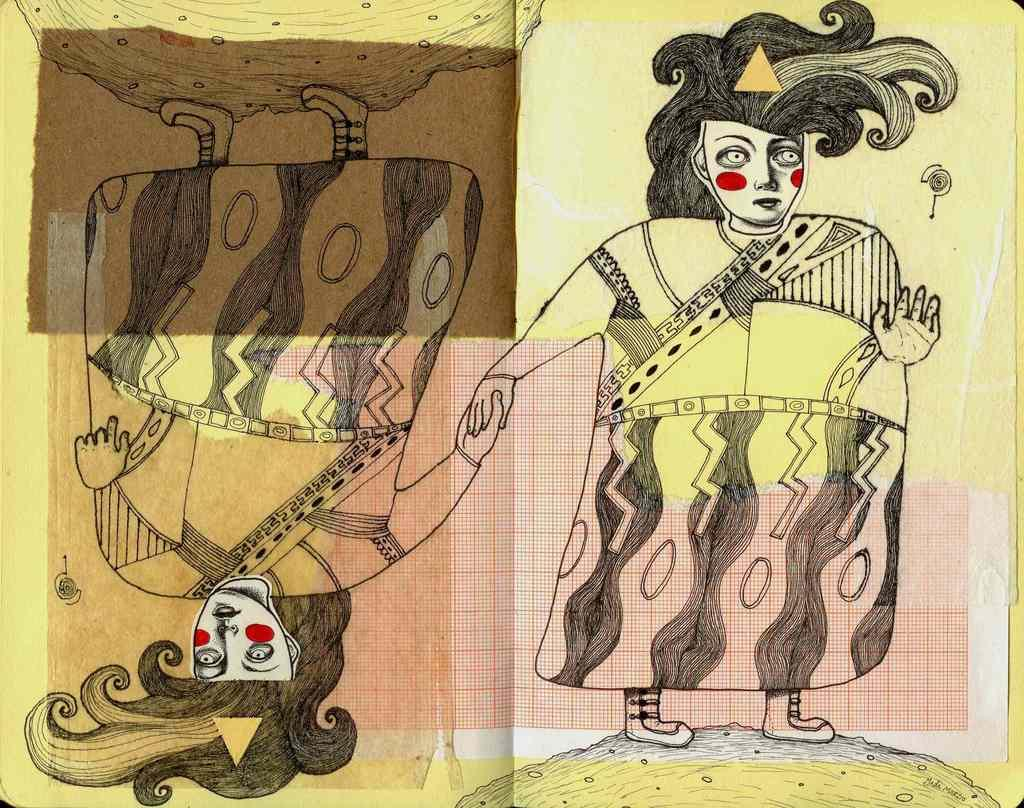What can be seen in the image that appears to be hand-drawn? There are drawings in the image. What type of paper is visible in the image? There is a piece of graph paper in the image. How does the rhythm of the vase affect the pollution in the image? There is no vase or pollution present in the image, so this question cannot be answered. 